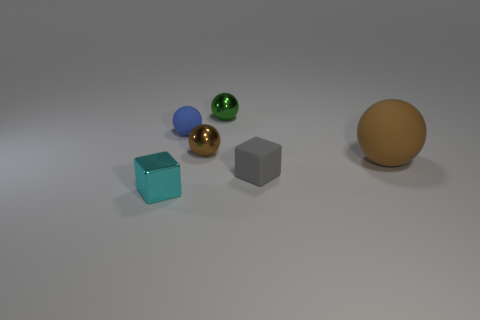How many objects are there, and which one is the largest? In total, there are five objects in the image. The largest object is the sphere on the far right, which has a matte surface and a golden-brown color. 